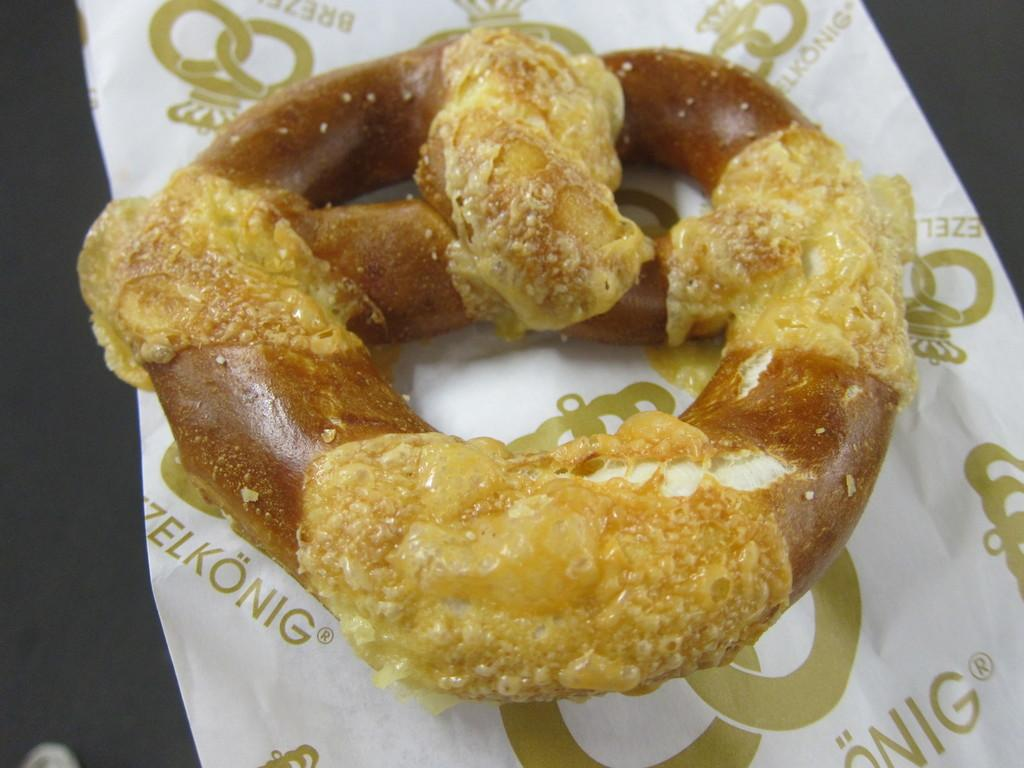What is the main subject of the image? The main subject of the image is food. What is the food placed on? The food is placed on a white color paper. Is there any text or writing on the paper? Yes, there is writing on the paper. What is the color of the food? The food has a brown color. Who is the self-proclaimed winner of the competition in the image? There is no reference to a competition or a self-proclaimed winner in the image. 